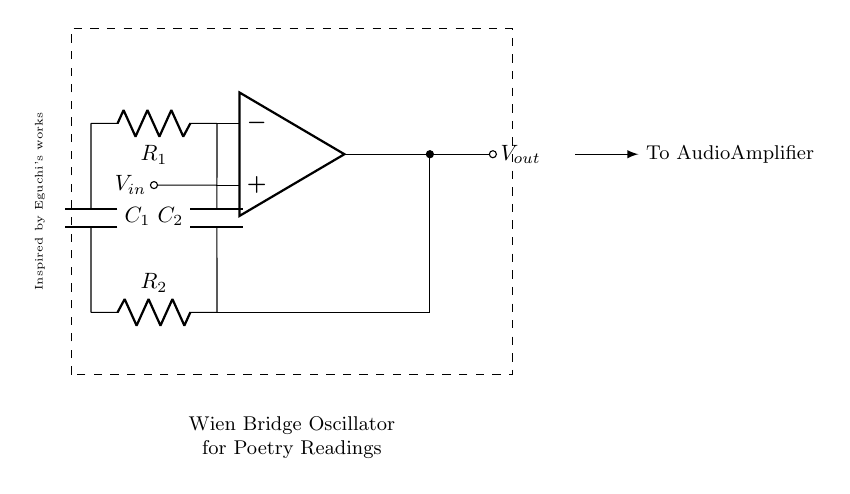What is the function of the op-amp in this circuit? The op-amp serves as an amplifier to produce output voltage that is proportional to the input voltage, enabling the generation of oscillations in the Wien bridge oscillator.
Answer: Amplifier How many resistors are present in the circuit? The circuit contains two resistors, R1 and R2, which are essential for the balanced condition needed to generate oscillations.
Answer: Two What type of oscillator is represented in the diagram? The diagram depicts a Wien bridge oscillator, a specific type of electronic oscillator that utilizes a Wien network for generating sine waves.
Answer: Wien bridge What is the role of the capacitors in this circuit? The capacitors C1 and C2 are involved in the timing characteristics of the oscillator, helping to set the frequency of the signal produced by the circuit.
Answer: Timing Which component is responsible for outputting the audio signal? The output voltage is taken from the op-amp's output, which feeds into an audio amplifier, thus producing the desired audio tone.
Answer: Op-amp What is the significance of the dashed rectangle around the circuit? The dashed rectangle indicates the boundaries of the circuit module, emphasizing the components that form the Wien bridge oscillator within a single functional unit.
Answer: Circuit boundaries 